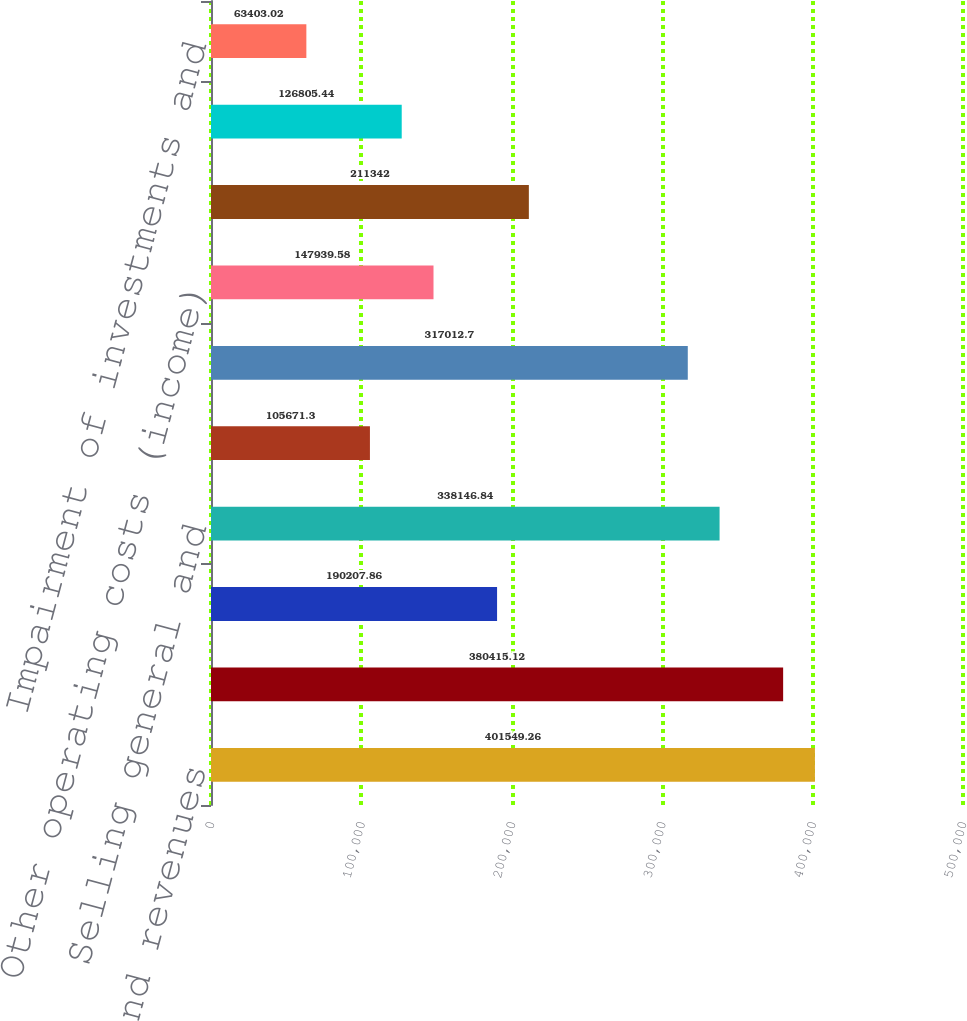Convert chart to OTSL. <chart><loc_0><loc_0><loc_500><loc_500><bar_chart><fcel>Net sales and revenues<fcel>Costs of products sold<fcel>Gross Margin<fcel>Selling general and<fcel>Research and development<fcel>Charges for restructuring<fcel>Other operating costs (income)<fcel>Operating income (loss)<fcel>Interest income and other<fcel>Impairment of investments and<nl><fcel>401549<fcel>380415<fcel>190208<fcel>338147<fcel>105671<fcel>317013<fcel>147940<fcel>211342<fcel>126805<fcel>63403<nl></chart> 